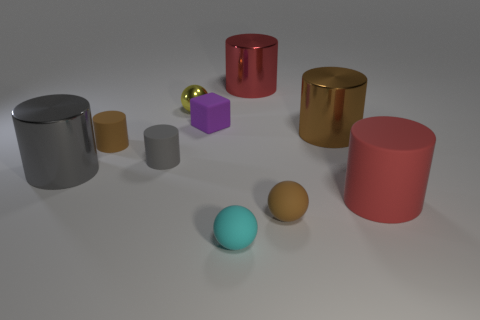What size is the gray metallic object that is the same shape as the big brown metal thing?
Provide a short and direct response. Large. There is a matte object that is behind the tiny cyan sphere and in front of the big red rubber cylinder; what size is it?
Give a very brief answer. Small. There is a large rubber cylinder; is its color the same as the object behind the small metal thing?
Keep it short and to the point. Yes. What number of red things are large shiny cubes or metallic cylinders?
Your response must be concise. 1. What is the shape of the cyan thing?
Your response must be concise. Sphere. How many other objects are there of the same shape as the tiny cyan matte thing?
Your answer should be compact. 2. What is the color of the big cylinder behind the brown shiny cylinder?
Keep it short and to the point. Red. Is the small yellow thing made of the same material as the tiny cyan sphere?
Your answer should be compact. No. What number of things are purple matte blocks or rubber cylinders on the right side of the brown shiny object?
Keep it short and to the point. 2. The metallic object that is the same color as the big rubber cylinder is what size?
Your response must be concise. Large. 